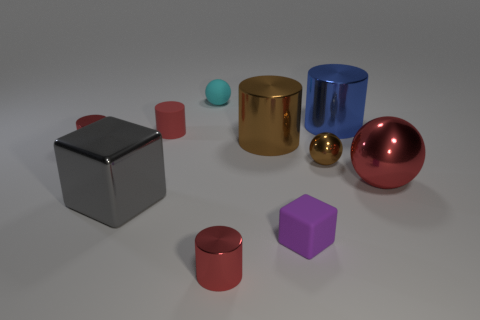There is a cylinder that is the same color as the small metal ball; what is its material? The cylinder that shares the same color as the small metal ball appears to be made of metal as well. This is suggested by the similar sheen and reflective qualities that are characteristic of metallic objects. 